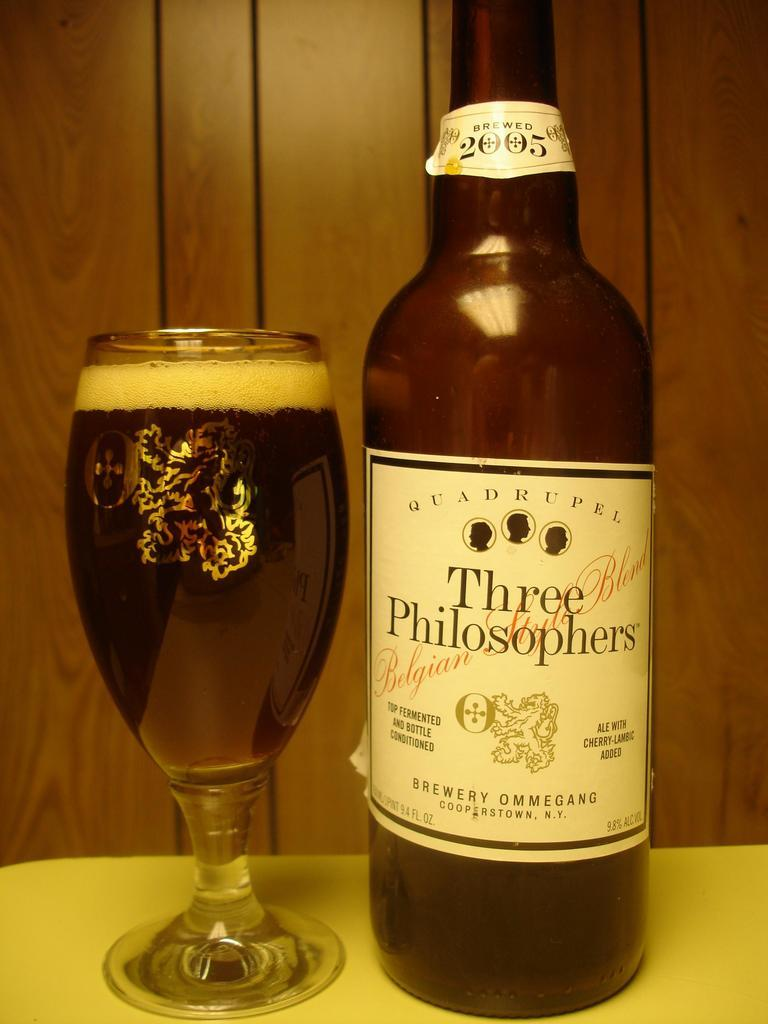<image>
Summarize the visual content of the image. An empty bottle of Three Philosophers Ale next to a full glass. 